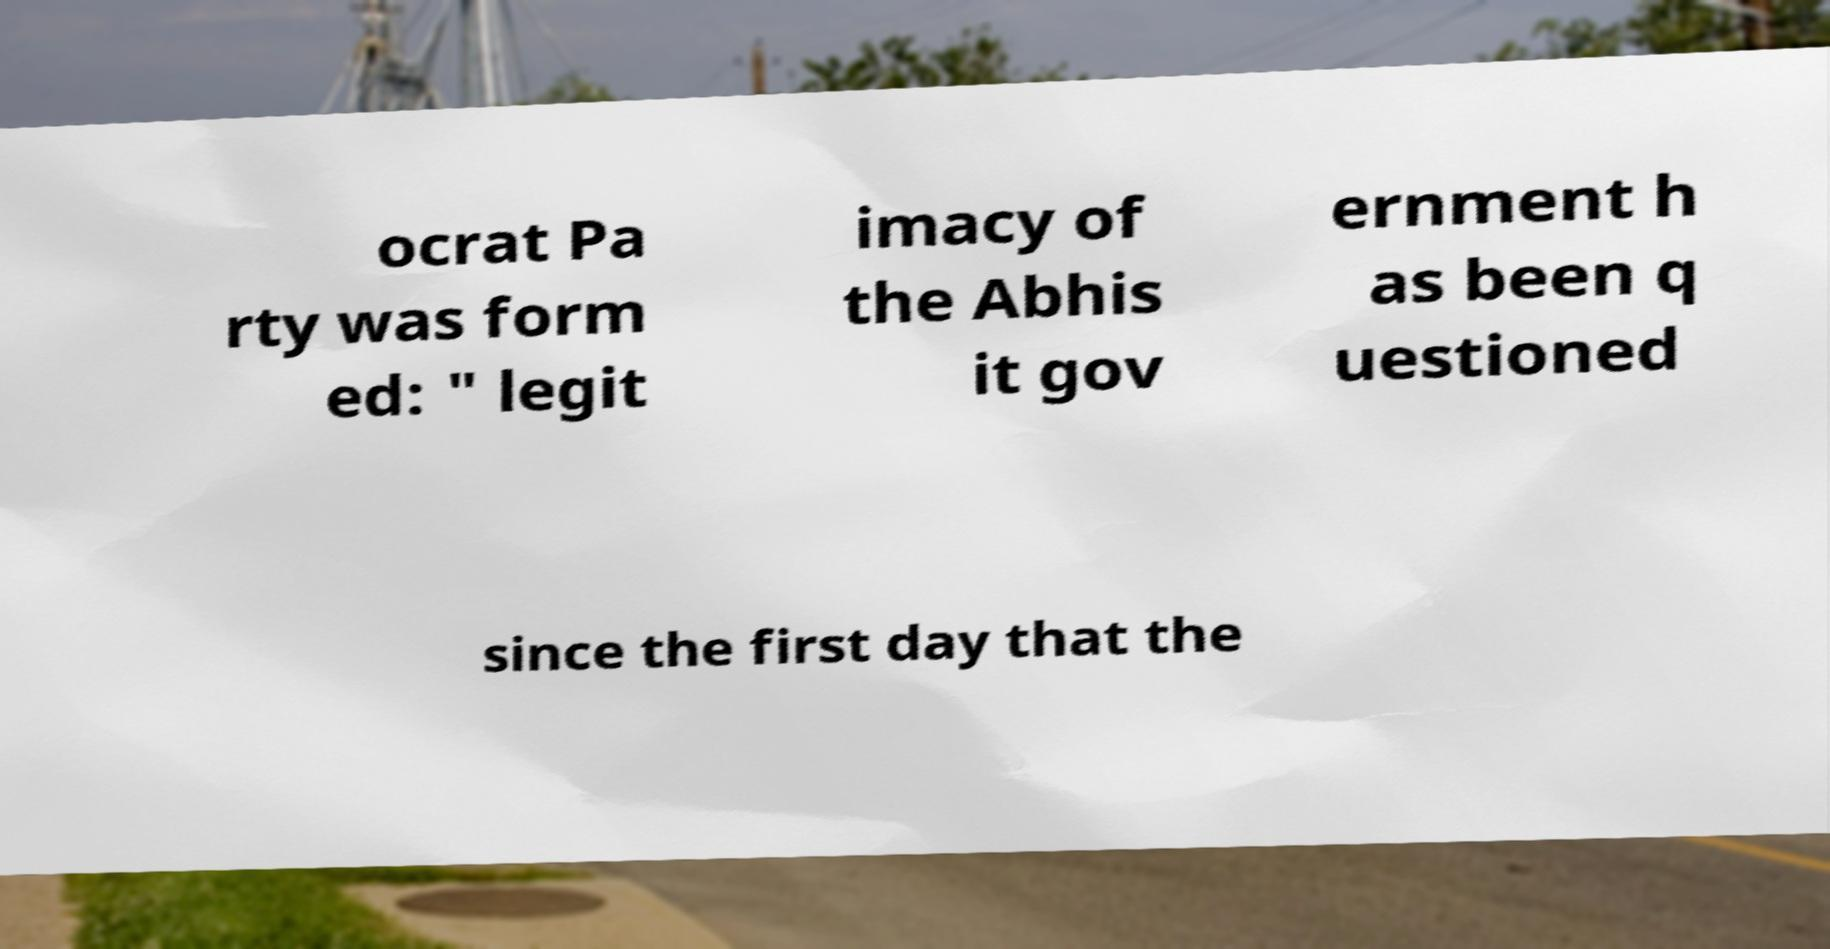For documentation purposes, I need the text within this image transcribed. Could you provide that? ocrat Pa rty was form ed: " legit imacy of the Abhis it gov ernment h as been q uestioned since the first day that the 